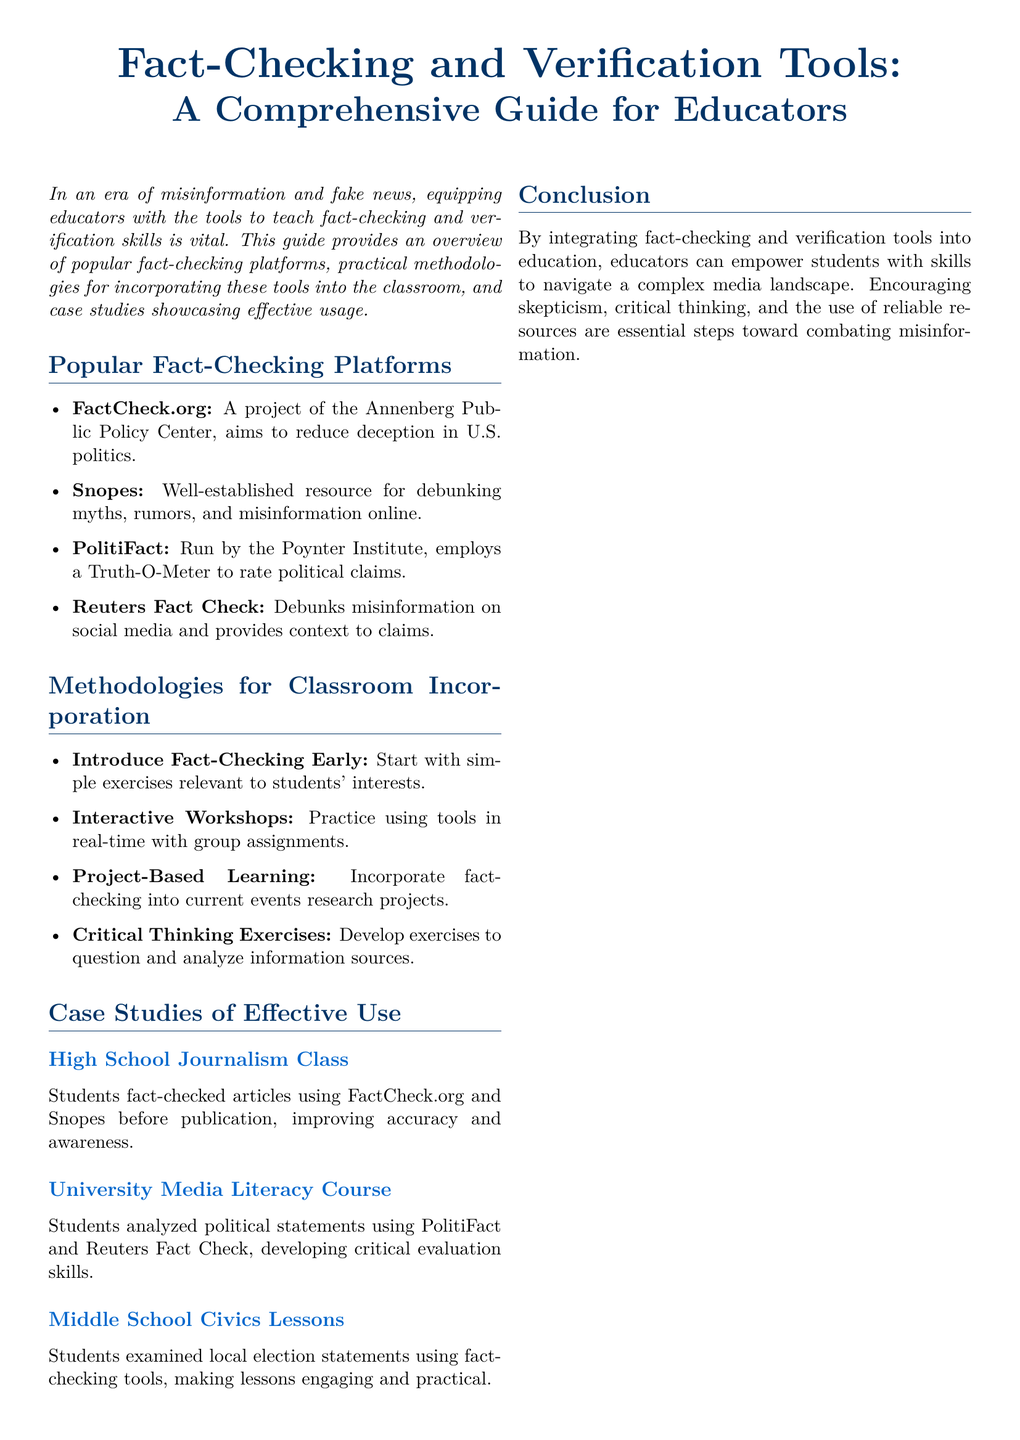What is the title of the guide? The title of the guide is presented at the top of the document, which indicates its focus on fact-checking and verification.
Answer: Fact-Checking and Verification Tools: A Comprehensive Guide for Educators Which platform is associated with the Annenberg Public Policy Center? The document mentions FactCheck.org as a project of the Annenberg Public Policy Center, focusing on political deception.
Answer: FactCheck.org What is the Truth-O-Meter used for? The Truth-O-Meter is referenced in the context of PolitiFact, which rates political claims for truthfulness.
Answer: To rate political claims How many case studies are presented in the document? A count of the specific case studies mentioned will show the number of examples provided for effective use of fact-checking in education.
Answer: Three What type of learning is suggested for incorporating fact-checking into education? The document lists several methodologies, one of which explicitly mentions a hands-on learning approach.
Answer: Project-Based Learning Which platform is known for debunking myths and rumors? The document clearly states that Snopes is renowned for addressing myths and misinformation.
Answer: Snopes In which class did students use FactCheck.org and Snopes? The guide highlights a specific example of a class where these platforms were utilized.
Answer: High School Journalism Class What is one of the recommended early exercises for fact-checking? The document suggests starting with introductory exercises that connect with students' interests as a way to engage them.
Answer: Introduce Fact-Checking Early 